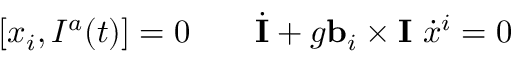<formula> <loc_0><loc_0><loc_500><loc_500>[ x _ { i } , I ^ { a } ( t ) ] = 0 \quad \dot { I } + g { b } _ { i } \times { I } \ \dot { x } ^ { i } = 0</formula> 